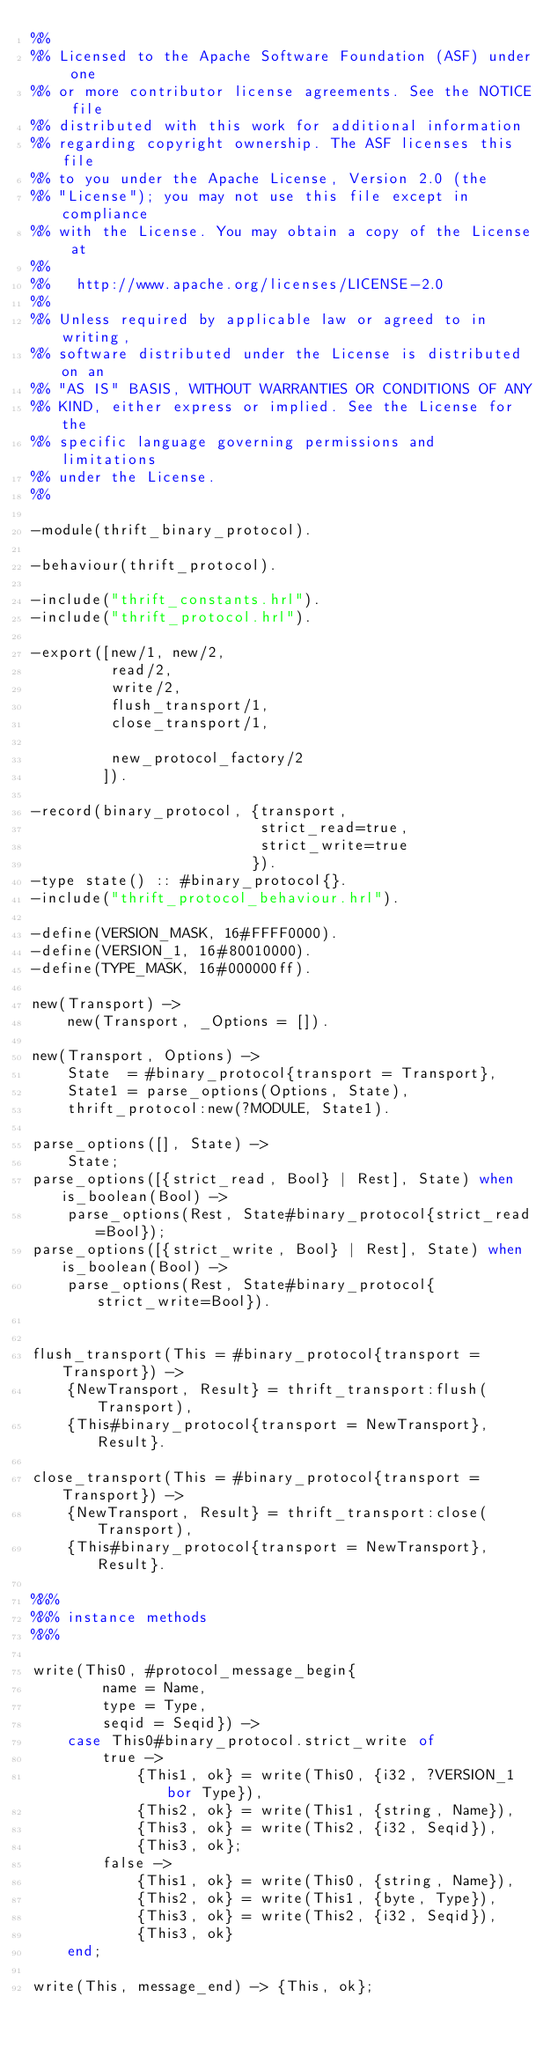<code> <loc_0><loc_0><loc_500><loc_500><_Erlang_>%%
%% Licensed to the Apache Software Foundation (ASF) under one
%% or more contributor license agreements. See the NOTICE file
%% distributed with this work for additional information
%% regarding copyright ownership. The ASF licenses this file
%% to you under the Apache License, Version 2.0 (the
%% "License"); you may not use this file except in compliance
%% with the License. You may obtain a copy of the License at
%%
%%   http://www.apache.org/licenses/LICENSE-2.0
%%
%% Unless required by applicable law or agreed to in writing,
%% software distributed under the License is distributed on an
%% "AS IS" BASIS, WITHOUT WARRANTIES OR CONDITIONS OF ANY
%% KIND, either express or implied. See the License for the
%% specific language governing permissions and limitations
%% under the License.
%%

-module(thrift_binary_protocol).

-behaviour(thrift_protocol).

-include("thrift_constants.hrl").
-include("thrift_protocol.hrl").

-export([new/1, new/2,
         read/2,
         write/2,
         flush_transport/1,
         close_transport/1,

         new_protocol_factory/2
        ]).

-record(binary_protocol, {transport,
                          strict_read=true,
                          strict_write=true
                         }).
-type state() :: #binary_protocol{}.
-include("thrift_protocol_behaviour.hrl").

-define(VERSION_MASK, 16#FFFF0000).
-define(VERSION_1, 16#80010000).
-define(TYPE_MASK, 16#000000ff).

new(Transport) ->
    new(Transport, _Options = []).

new(Transport, Options) ->
    State  = #binary_protocol{transport = Transport},
    State1 = parse_options(Options, State),
    thrift_protocol:new(?MODULE, State1).

parse_options([], State) ->
    State;
parse_options([{strict_read, Bool} | Rest], State) when is_boolean(Bool) ->
    parse_options(Rest, State#binary_protocol{strict_read=Bool});
parse_options([{strict_write, Bool} | Rest], State) when is_boolean(Bool) ->
    parse_options(Rest, State#binary_protocol{strict_write=Bool}).


flush_transport(This = #binary_protocol{transport = Transport}) ->
    {NewTransport, Result} = thrift_transport:flush(Transport),
    {This#binary_protocol{transport = NewTransport}, Result}.

close_transport(This = #binary_protocol{transport = Transport}) ->
    {NewTransport, Result} = thrift_transport:close(Transport),
    {This#binary_protocol{transport = NewTransport}, Result}.

%%%
%%% instance methods
%%%

write(This0, #protocol_message_begin{
        name = Name,
        type = Type,
        seqid = Seqid}) ->
    case This0#binary_protocol.strict_write of
        true ->
            {This1, ok} = write(This0, {i32, ?VERSION_1 bor Type}),
            {This2, ok} = write(This1, {string, Name}),
            {This3, ok} = write(This2, {i32, Seqid}),
            {This3, ok};
        false ->
            {This1, ok} = write(This0, {string, Name}),
            {This2, ok} = write(This1, {byte, Type}),
            {This3, ok} = write(This2, {i32, Seqid}),
            {This3, ok}
    end;

write(This, message_end) -> {This, ok};
</code> 